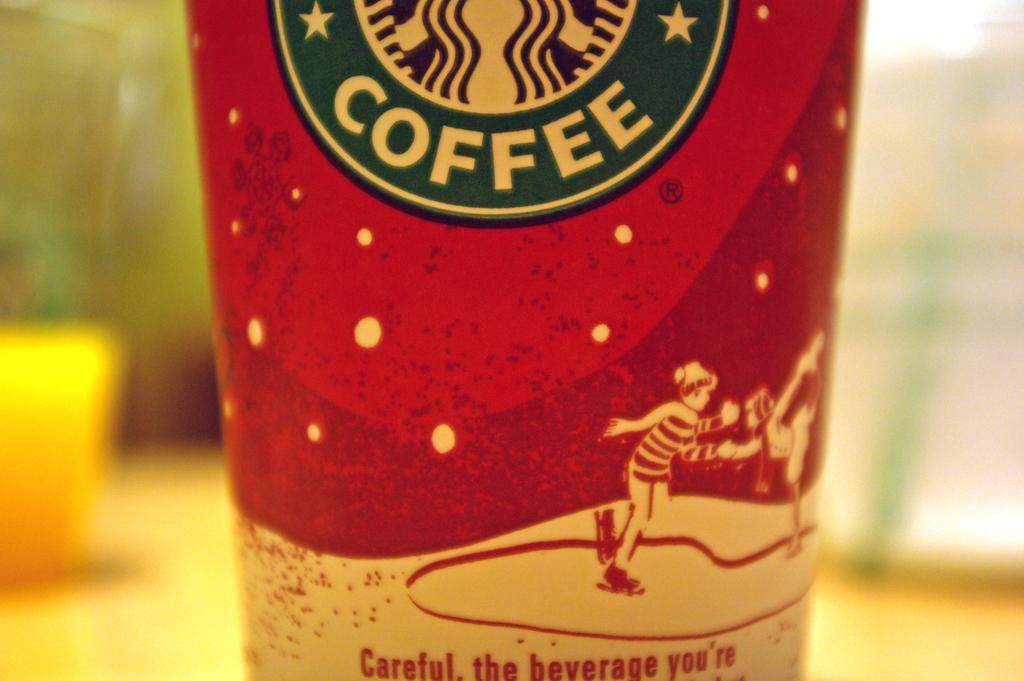<image>
Create a compact narrative representing the image presented. Starbucks Coffee cup showing a boy ice skating. 